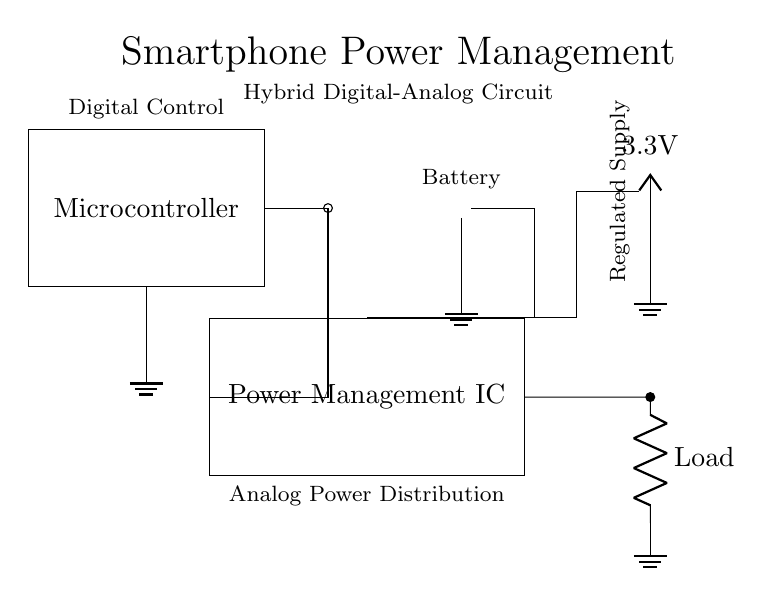What does the Microcontroller control? The Microcontroller controls the Power Management IC, indicated by the connection from the Microcontroller to the PMIC. This suggests a digital control system where the microcontroller sends signals to manage power delivery.
Answer: Power Management IC What is the primary voltage level represented in this circuit? The primary voltage level represented is 3.3V, which is indicated by the labeled VCC node in the circuit diagram. This voltage is typically used in digital circuits and reflects the regulated power supply for the system.
Answer: 3.3V What component provides power to the circuit? The component providing power to the circuit is the Battery, represented by the battery symbol in the diagram. It is connected to the Power Management IC and supplies the necessary energy for operation.
Answer: Battery How many different power sources are indicated in this circuit? There are two different power sources indicated in this circuit: the Battery and the Regulated Supply (3.3V). Each plays a role in supplying different power needs for the digital and analog components.
Answer: Two What role does the Power Management IC serve in the circuit? The Power Management IC regulates and distributes power from the Battery and VCC to various components, ensuring that they receive the appropriate voltage and current as required for proper operation. It is placed centrally between the power sources and the load.
Answer: Regulates power What is the load in this circuit indicated by? The load in this circuit is indicated by a circular symbol labeled Load, which signifies the element consuming electrical power. The connection from the Power Management IC to the load shows how it powers that component.
Answer: Load 